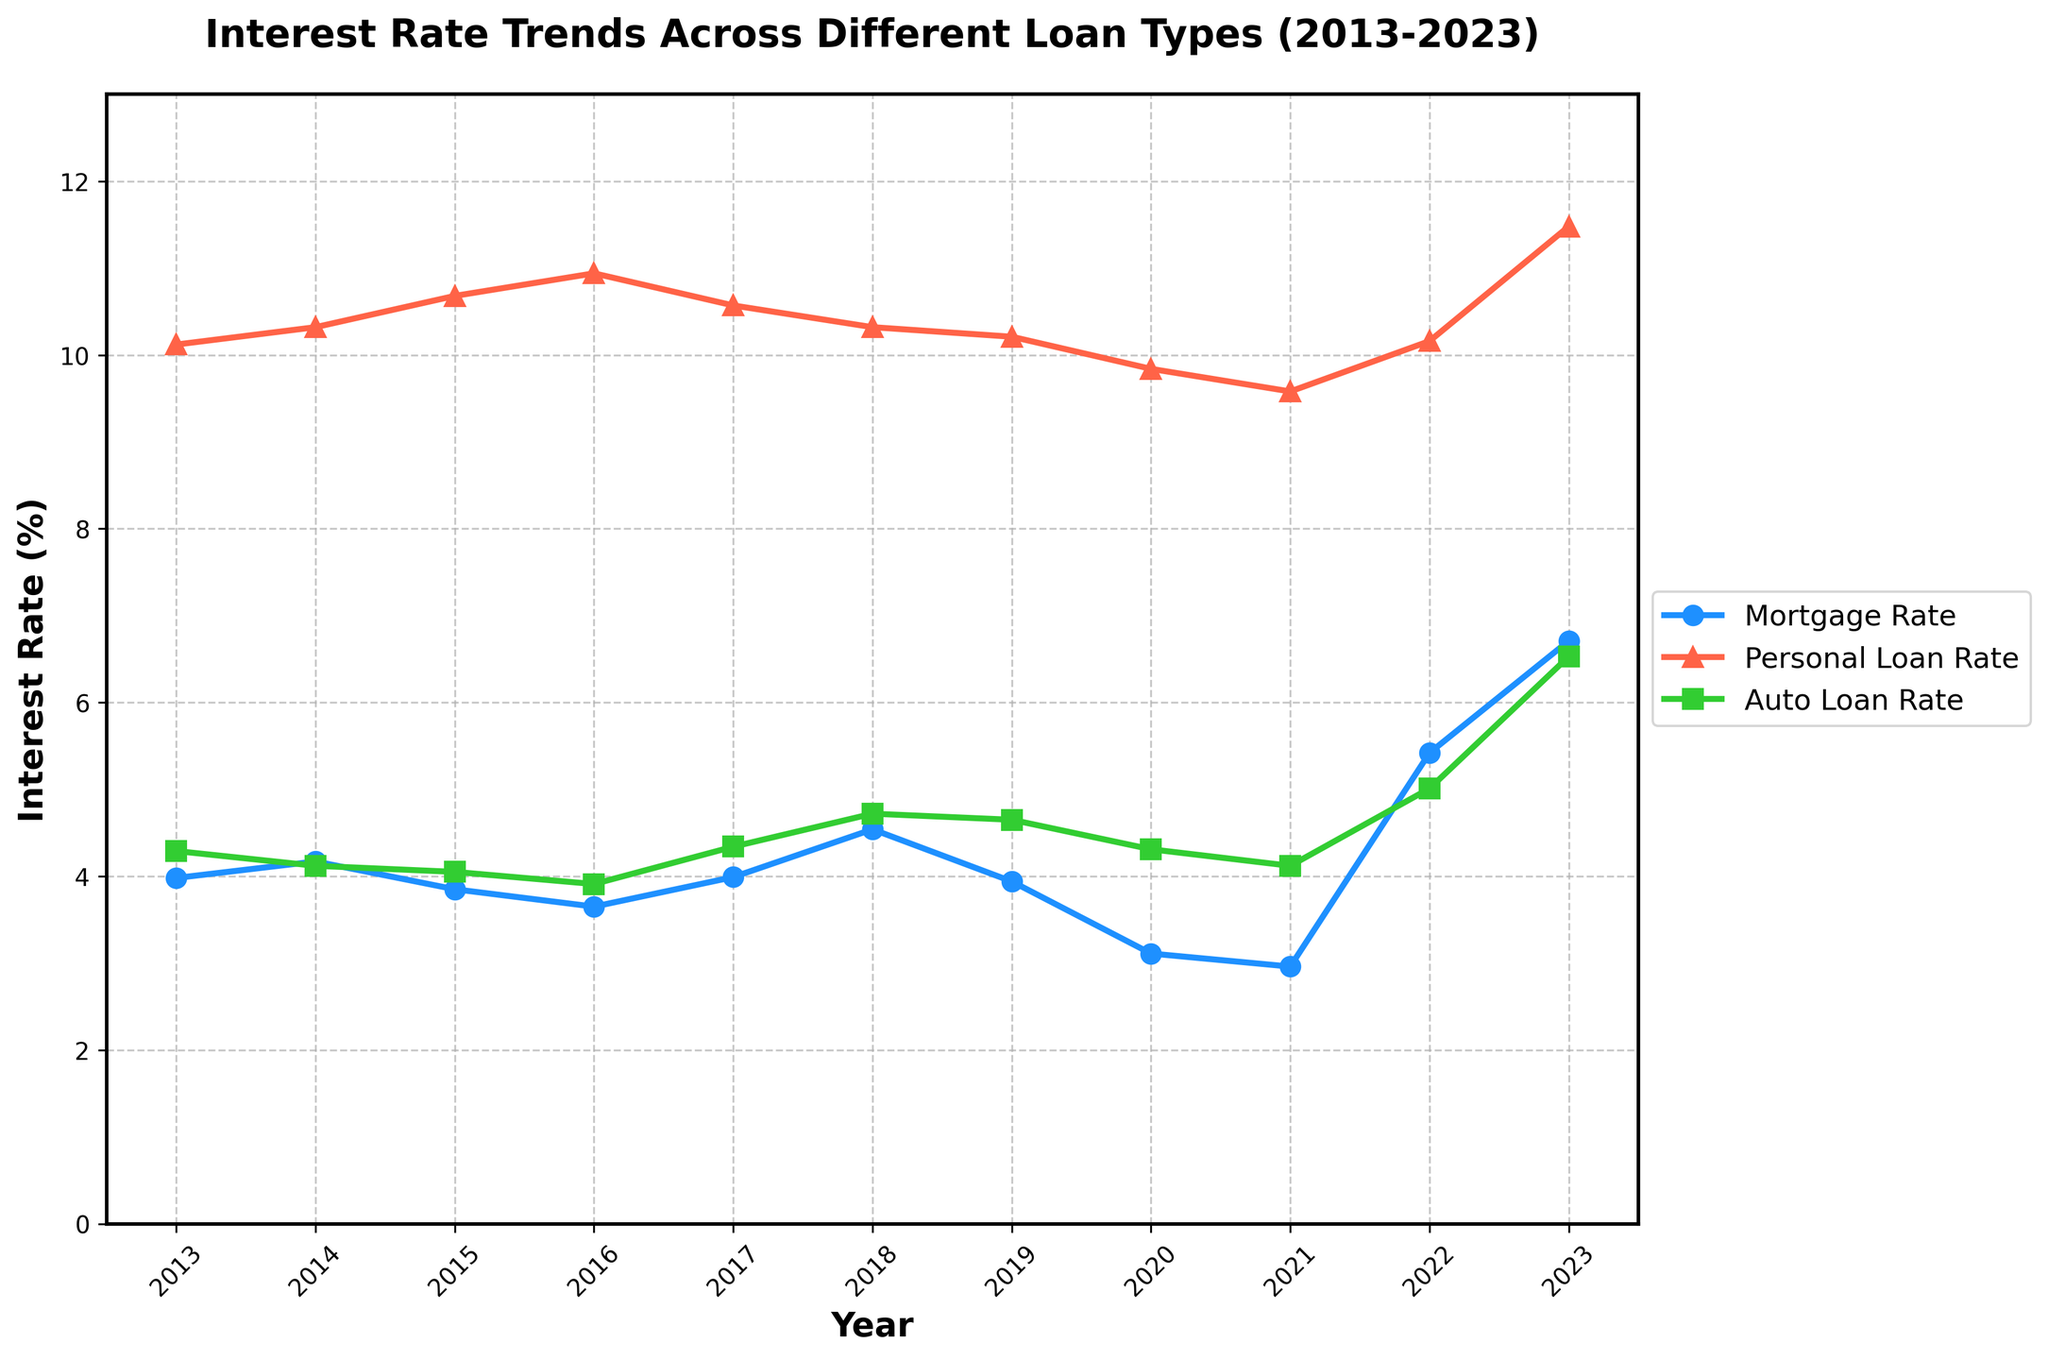What was the trend in mortgage rates between 2013 and 2023? Mortgage rates saw a general decline from 2013 (3.98%) to 2021 (2.96%), followed by a sharp increase reaching 6.71% in 2023.
Answer: Decline then sharp rise Which year had the lowest personal loan rate? The figure shows that personal loan rates were lowest in 2021, at 9.58%.
Answer: 2021 Which type of loan had the highest interest rate in 2023? The personal loan rate is highest in 2023 at 11.48% compared to mortgage and auto loan rates.
Answer: Personal Loan What is the difference between the highest and lowest mortgage rates over the period shown? The highest mortgage rate is 6.71% in 2023, and the lowest is 2.96% in 2021. The difference is 6.71% - 2.96% = 3.75%.
Answer: 3.75% During which years were auto loan rates consistently below 4%? Auto loan rates were consistently below 4% from 2015 (4.05%) to 2016 (3.91%).
Answer: 2016 What was the average mortgage rate from 2013 to 2023? Sum the mortgage rates for each year (3.98 + 4.17 + 3.85 + 3.65 + 3.99 + 4.54 + 3.94 + 3.11 + 2.96 + 5.42 + 6.71) = 46.32. Divide by the number of years (11). The average is 46.32/11 ≈ 4.21%.
Answer: 4.21% Which loan type saw the most significant increase in rates from 2021 to 2023? Mortgage rates increased from 2.96% in 2021 to 6.71% in 2023, an increase of 3.75%. Personal loans went from 9.58% to 11.48%, an increase of 1.90%. Auto loans saw an increase from 4.12% to 6.53%, an increase of 2.41%. The most significant increase was in mortgage rates (3.75%).
Answer: Mortgage Rate In which year did all three loan types have their rates close to each other? Comparing the plots, in 2018, the rates were 4.54% (Mortgage), 10.32% (Personal), and 4.72% (Auto), which were relatively closer than other years.
Answer: 2018 How did the auto loan rates change from 2017 to 2023? Auto loan rates increased from 4.34% in 2017 to 6.53% in 2023.
Answer: Increased 